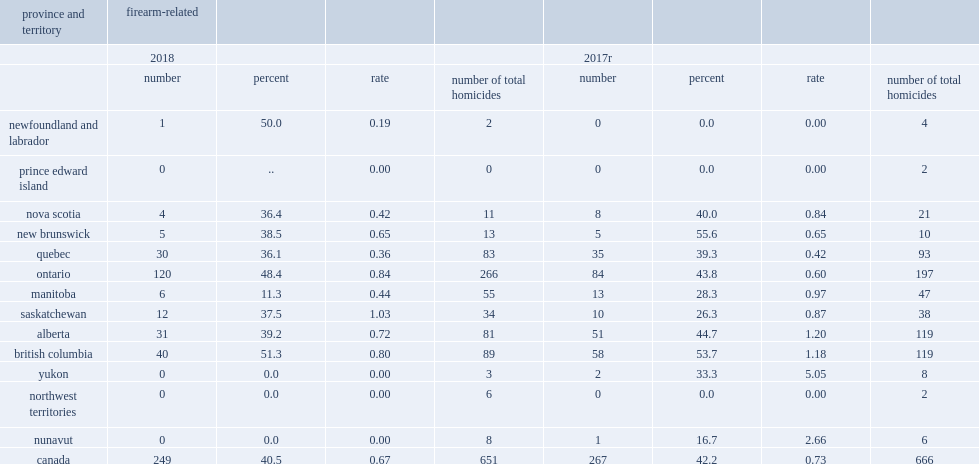What was the number of homicides caused by a firearm (firearm-related) in 2018? 249.0. 